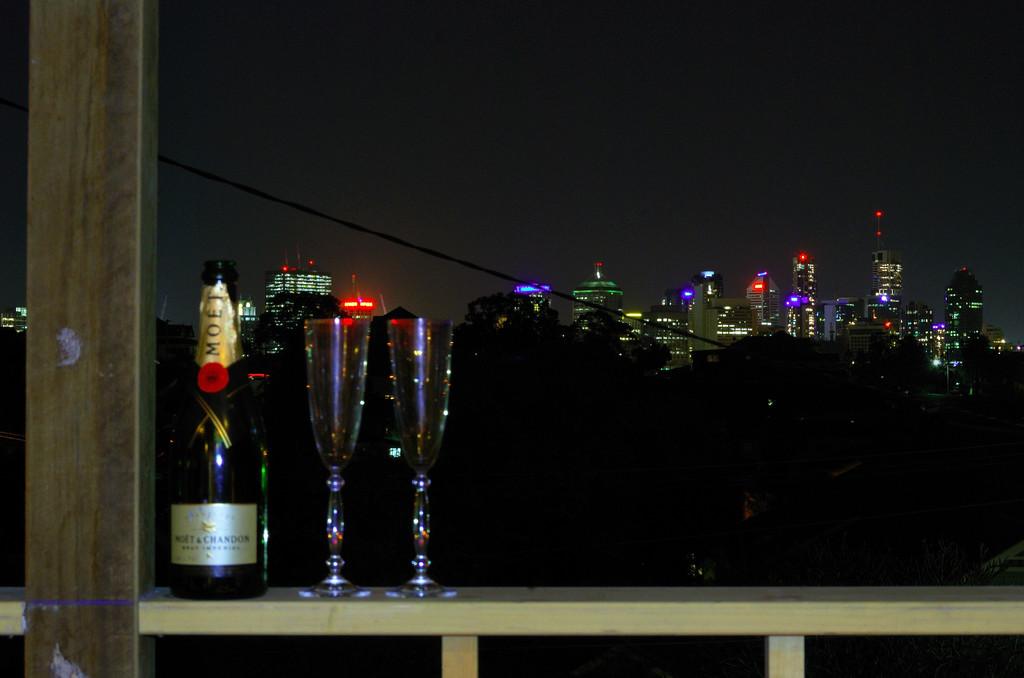What brand of drink is this?
Make the answer very short. Moet. What kind of wine is in the bottle?
Your response must be concise. Moet. 